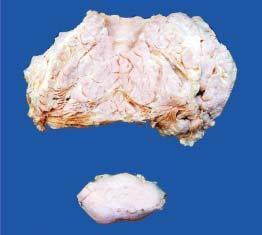s the main mass multilobulated with increased fat while lower part of the image shows a separate encapsulated gelatinous mass?
Answer the question using a single word or phrase. Yes 